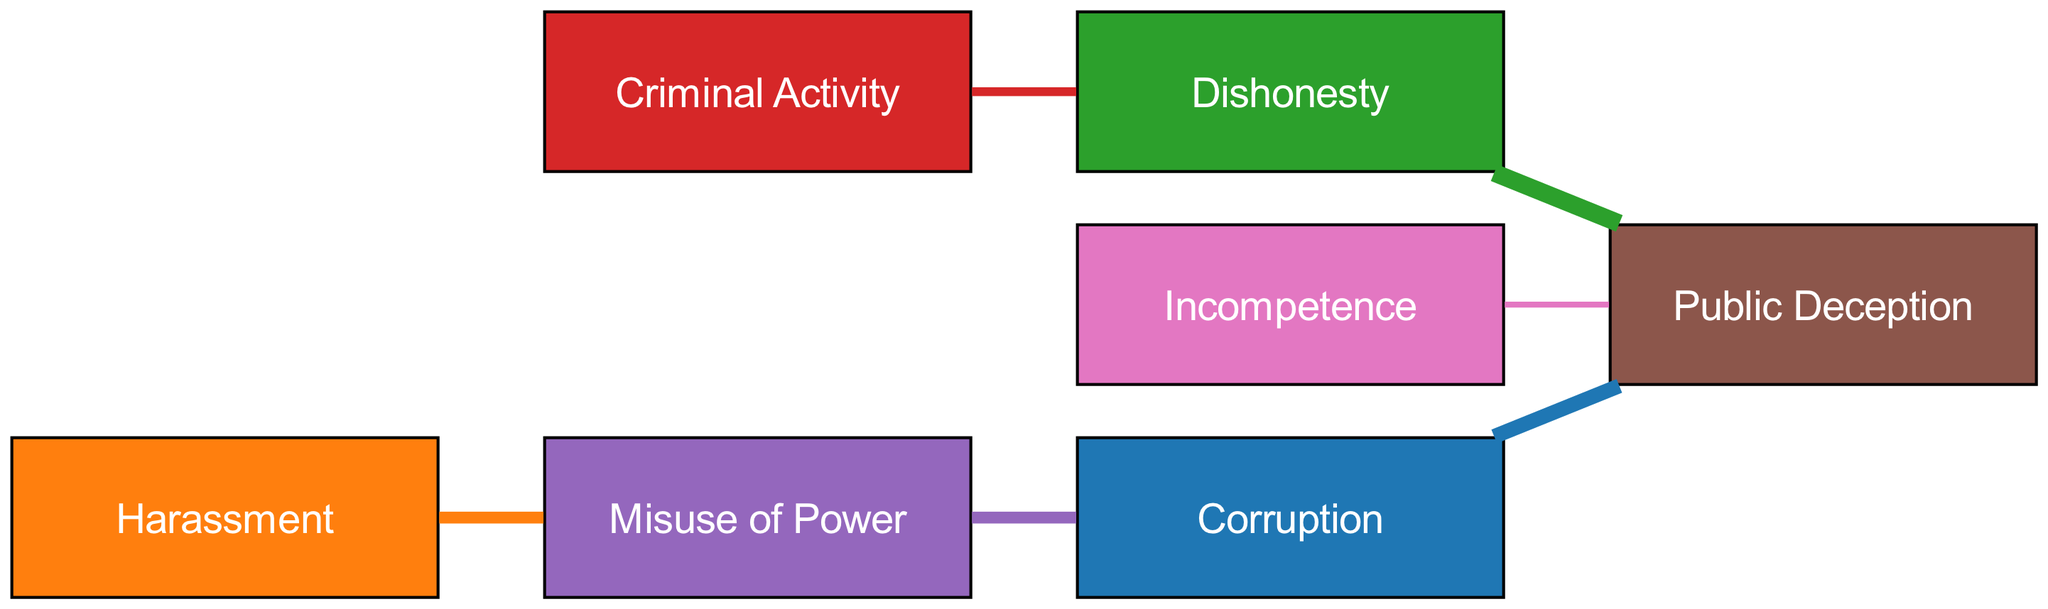What is the total number of nodes in the diagram? Counting the nodes listed under "nodes," we see there are seven distinct ethical concern categories.
Answer: 7 What type of offense is linked to "Dishonesty" with the highest value? "Dishonesty" is linked to "Public Deception" with a value of 6, higher than its other link to "Criminal Activity" with a value of 3.
Answer: Public Deception What is the value of the link from "Harassment" to "Misuse of Power"? The link from "Harassment" to "Misuse of Power" is represented by the value of 4, indicating a significant relationship.
Answer: 4 Which ethical concern is the most frequently linked type of offense in the diagram? "Public Deception" has the highest number of incoming links: 5 from "Corruption," 6 from "Dishonesty," and 2 from "Incompetence," making it the most linked concern.
Answer: Public Deception How many distinct links are depicted in the diagram? There are six links listed under "links," which connect various ethical concerns with their respective values.
Answer: 6 What is the total value of all links directed toward "Public Deception"? Summing the link values directed to "Public Deception," we have 5 (from Corruption) + 6 (from Dishonesty) + 2 (from Incompetence) = 13.
Answer: 13 Which type of offense shows a bidirectional relationship in the diagram? The relationship between "Corruption" and "Misuse of Power" is bidirectional, as "Corruption" flows to "Public Deception" while "Misuse of Power" flows to "Corruption."
Answer: Corruption and Misuse of Power Which ethical concern has the weakest direct relationship in the diagram? The direct relationship with the lowest value is from "Incompetence" to "Public Deception," which has a value of 2.
Answer: 2 